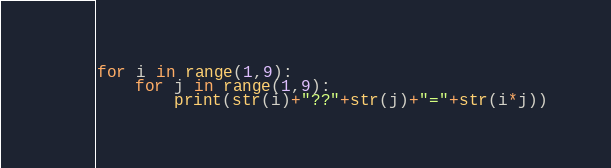<code> <loc_0><loc_0><loc_500><loc_500><_Python_>for i in range(1,9):
	for j in range(1,9):
		print(str(i)+"??"+str(j)+"="+str(i*j))</code> 